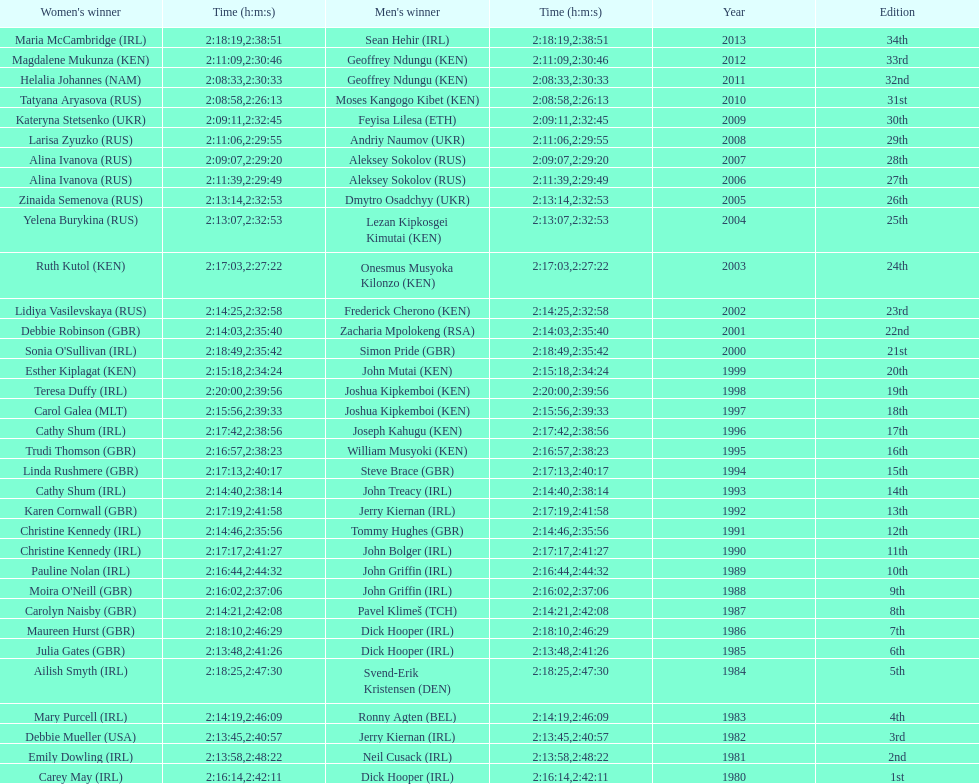Who won after joseph kipkemboi's winning streak ended? John Mutai (KEN). 